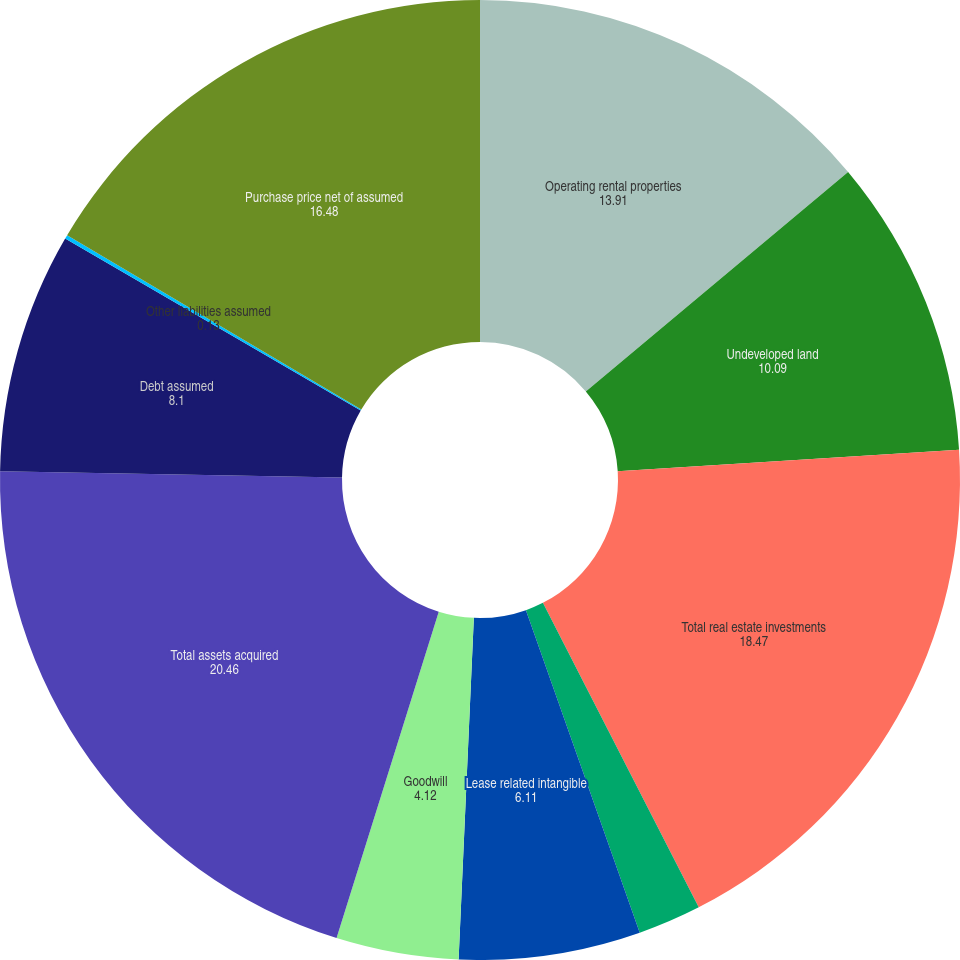Convert chart to OTSL. <chart><loc_0><loc_0><loc_500><loc_500><pie_chart><fcel>Operating rental properties<fcel>Undeveloped land<fcel>Total real estate investments<fcel>Other assets<fcel>Lease related intangible<fcel>Goodwill<fcel>Total assets acquired<fcel>Debt assumed<fcel>Other liabilities assumed<fcel>Purchase price net of assumed<nl><fcel>13.91%<fcel>10.09%<fcel>18.47%<fcel>2.13%<fcel>6.11%<fcel>4.12%<fcel>20.46%<fcel>8.1%<fcel>0.13%<fcel>16.48%<nl></chart> 